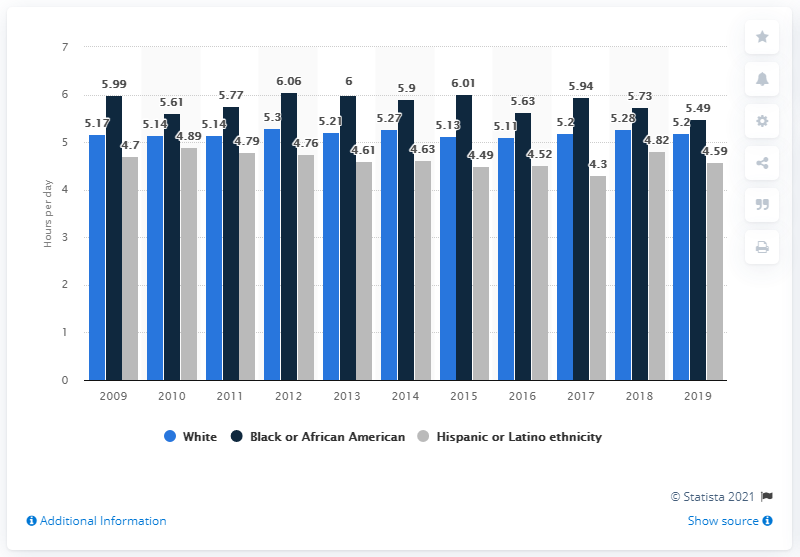List a handful of essential elements in this visual. According to the data, Black or African Americans spent an average of 5.49 hours per day on leisure and sports activities. The average amount of time Black people in the U.S. spent on leisure and sports per day from 2017 to 2019 was 5.72 hours, sorted by ethnicity. The value of the highest dark blue bar is 6.06... 